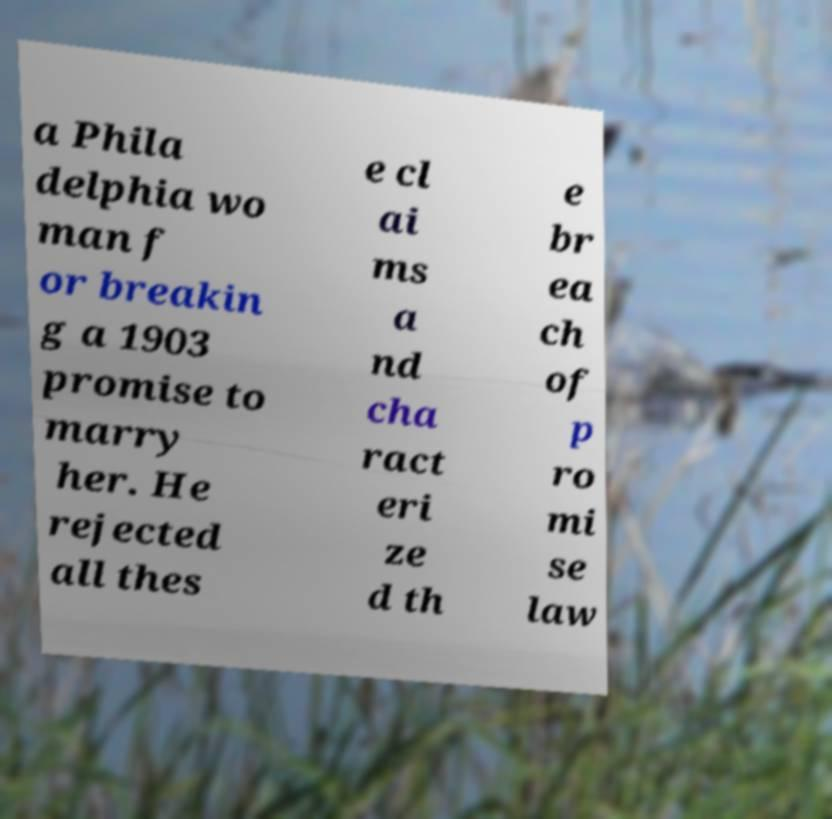What messages or text are displayed in this image? I need them in a readable, typed format. a Phila delphia wo man f or breakin g a 1903 promise to marry her. He rejected all thes e cl ai ms a nd cha ract eri ze d th e br ea ch of p ro mi se law 